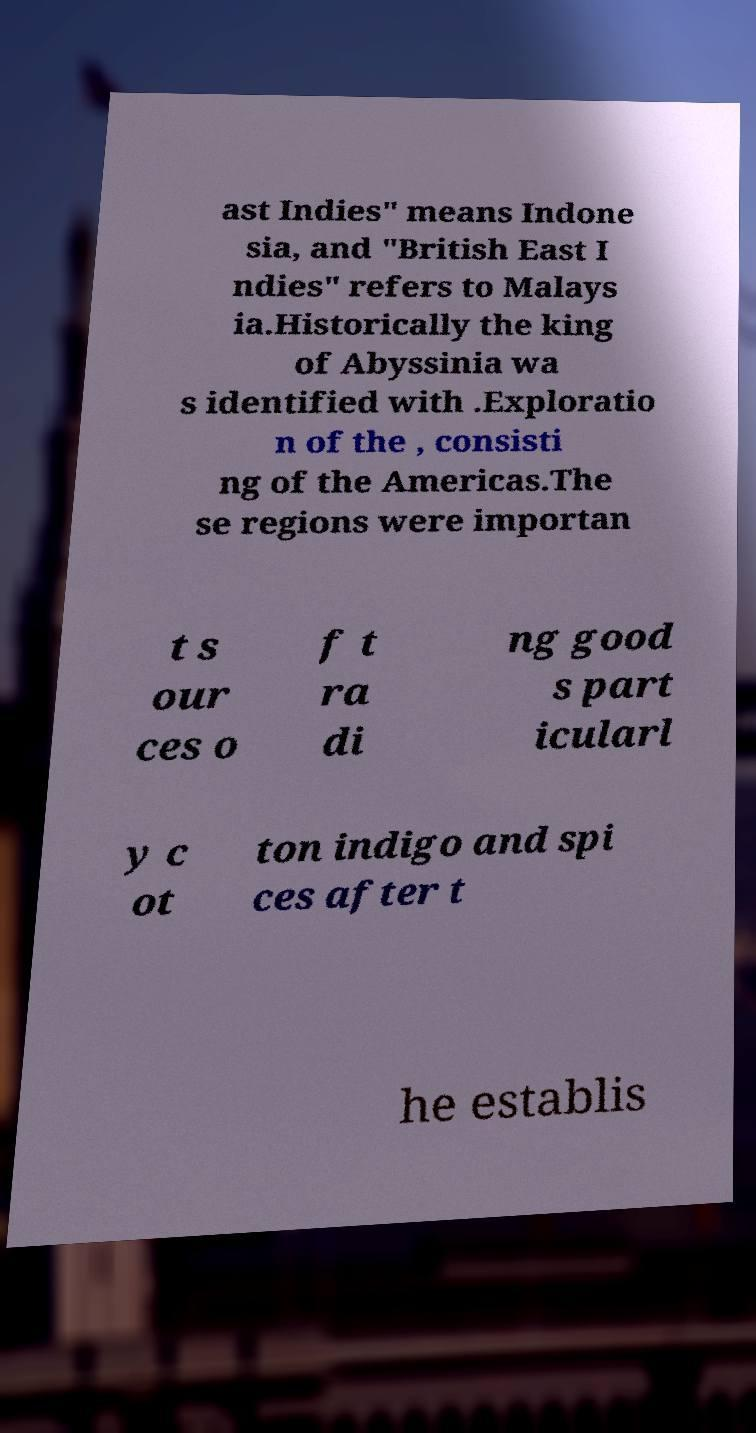Please identify and transcribe the text found in this image. ast Indies" means Indone sia, and "British East I ndies" refers to Malays ia.Historically the king of Abyssinia wa s identified with .Exploratio n of the , consisti ng of the Americas.The se regions were importan t s our ces o f t ra di ng good s part icularl y c ot ton indigo and spi ces after t he establis 